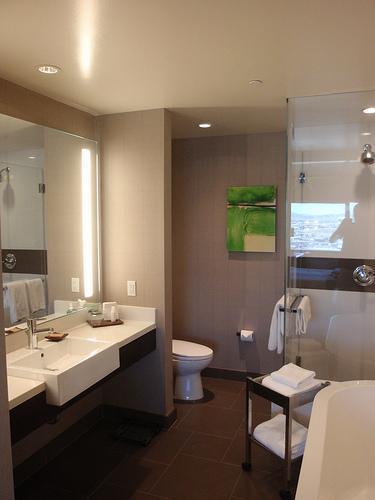How many toilets are there?
Give a very brief answer. 1. 